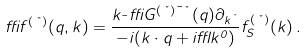Convert formula to latex. <formula><loc_0><loc_0><loc_500><loc_500>\delta f ^ { ( \nu ) } ( q , k ) = \frac { k _ { \mu } \delta G ^ { ( \nu ) \mu \nu } ( q ) \partial _ { k ^ { \nu } } } { - i ( k \cdot q + i \epsilon k ^ { 0 } ) } f ^ { ( \nu ) } _ { S } ( k ) \, .</formula> 